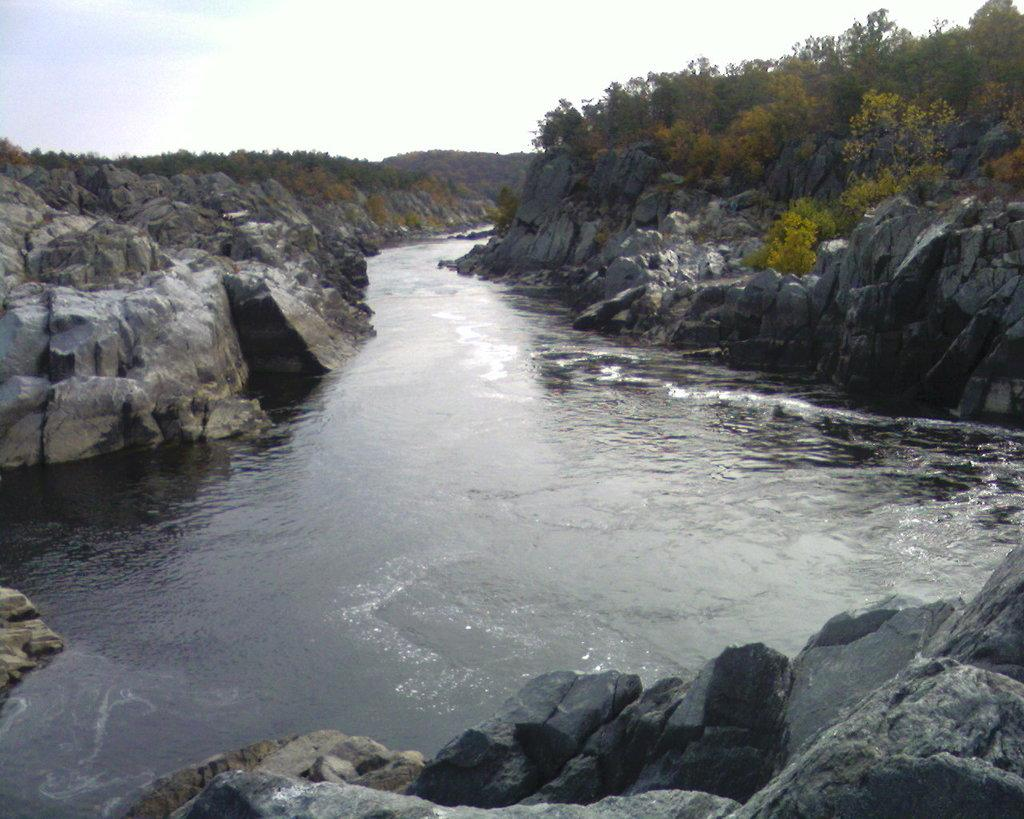Where was the image taken? The image was clicked outside. What can be seen on the right side of the image? There are trees on the right side of the image. What is in the middle of the image? There is water in the middle of the image. What is visible at the top of the image? The sky is visible at the top of the image. Can you see any flames in the image? There are no flames present in the image. What type of insect can be seen on the branch in the image? There is no branch or insect present in the image. 